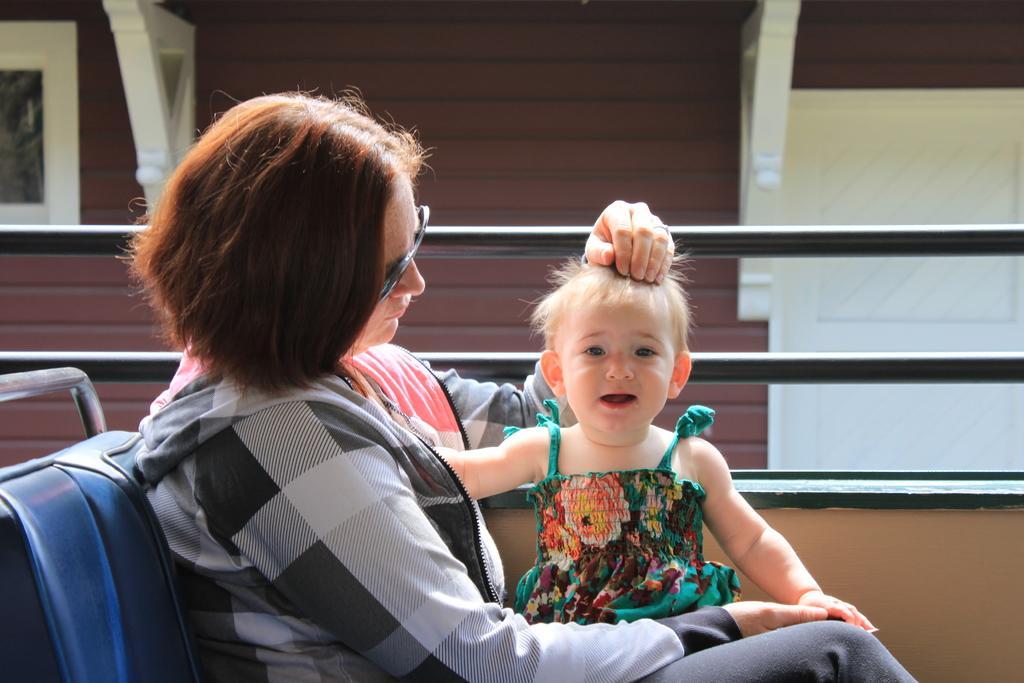Can you describe this image briefly? In this picture we can see a woman and a baby, she is seated and she wore spectacles, beside to her we can find few metal rods. 